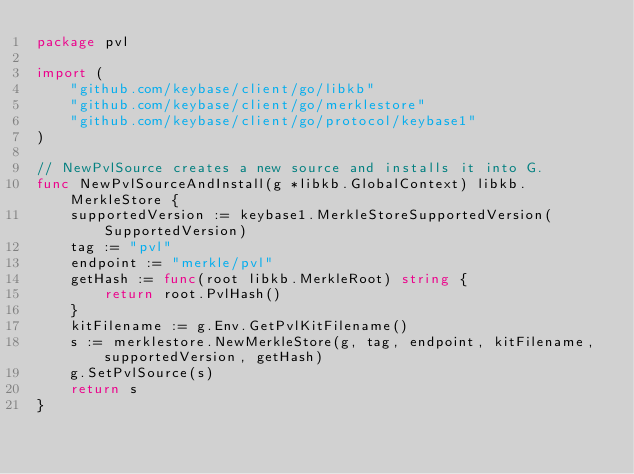Convert code to text. <code><loc_0><loc_0><loc_500><loc_500><_Go_>package pvl

import (
	"github.com/keybase/client/go/libkb"
	"github.com/keybase/client/go/merklestore"
	"github.com/keybase/client/go/protocol/keybase1"
)

// NewPvlSource creates a new source and installs it into G.
func NewPvlSourceAndInstall(g *libkb.GlobalContext) libkb.MerkleStore {
	supportedVersion := keybase1.MerkleStoreSupportedVersion(SupportedVersion)
	tag := "pvl"
	endpoint := "merkle/pvl"
	getHash := func(root libkb.MerkleRoot) string {
		return root.PvlHash()
	}
	kitFilename := g.Env.GetPvlKitFilename()
	s := merklestore.NewMerkleStore(g, tag, endpoint, kitFilename, supportedVersion, getHash)
	g.SetPvlSource(s)
	return s
}
</code> 